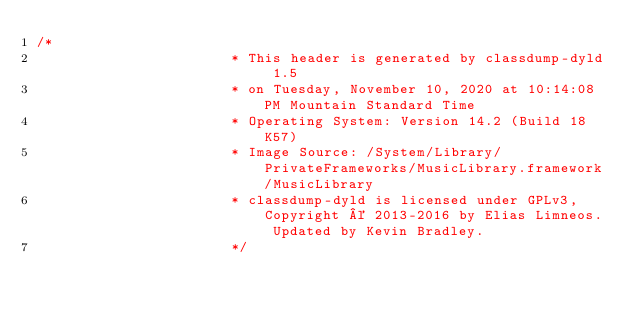Convert code to text. <code><loc_0><loc_0><loc_500><loc_500><_C_>/*
                       * This header is generated by classdump-dyld 1.5
                       * on Tuesday, November 10, 2020 at 10:14:08 PM Mountain Standard Time
                       * Operating System: Version 14.2 (Build 18K57)
                       * Image Source: /System/Library/PrivateFrameworks/MusicLibrary.framework/MusicLibrary
                       * classdump-dyld is licensed under GPLv3, Copyright © 2013-2016 by Elias Limneos. Updated by Kevin Bradley.
                       */
</code> 